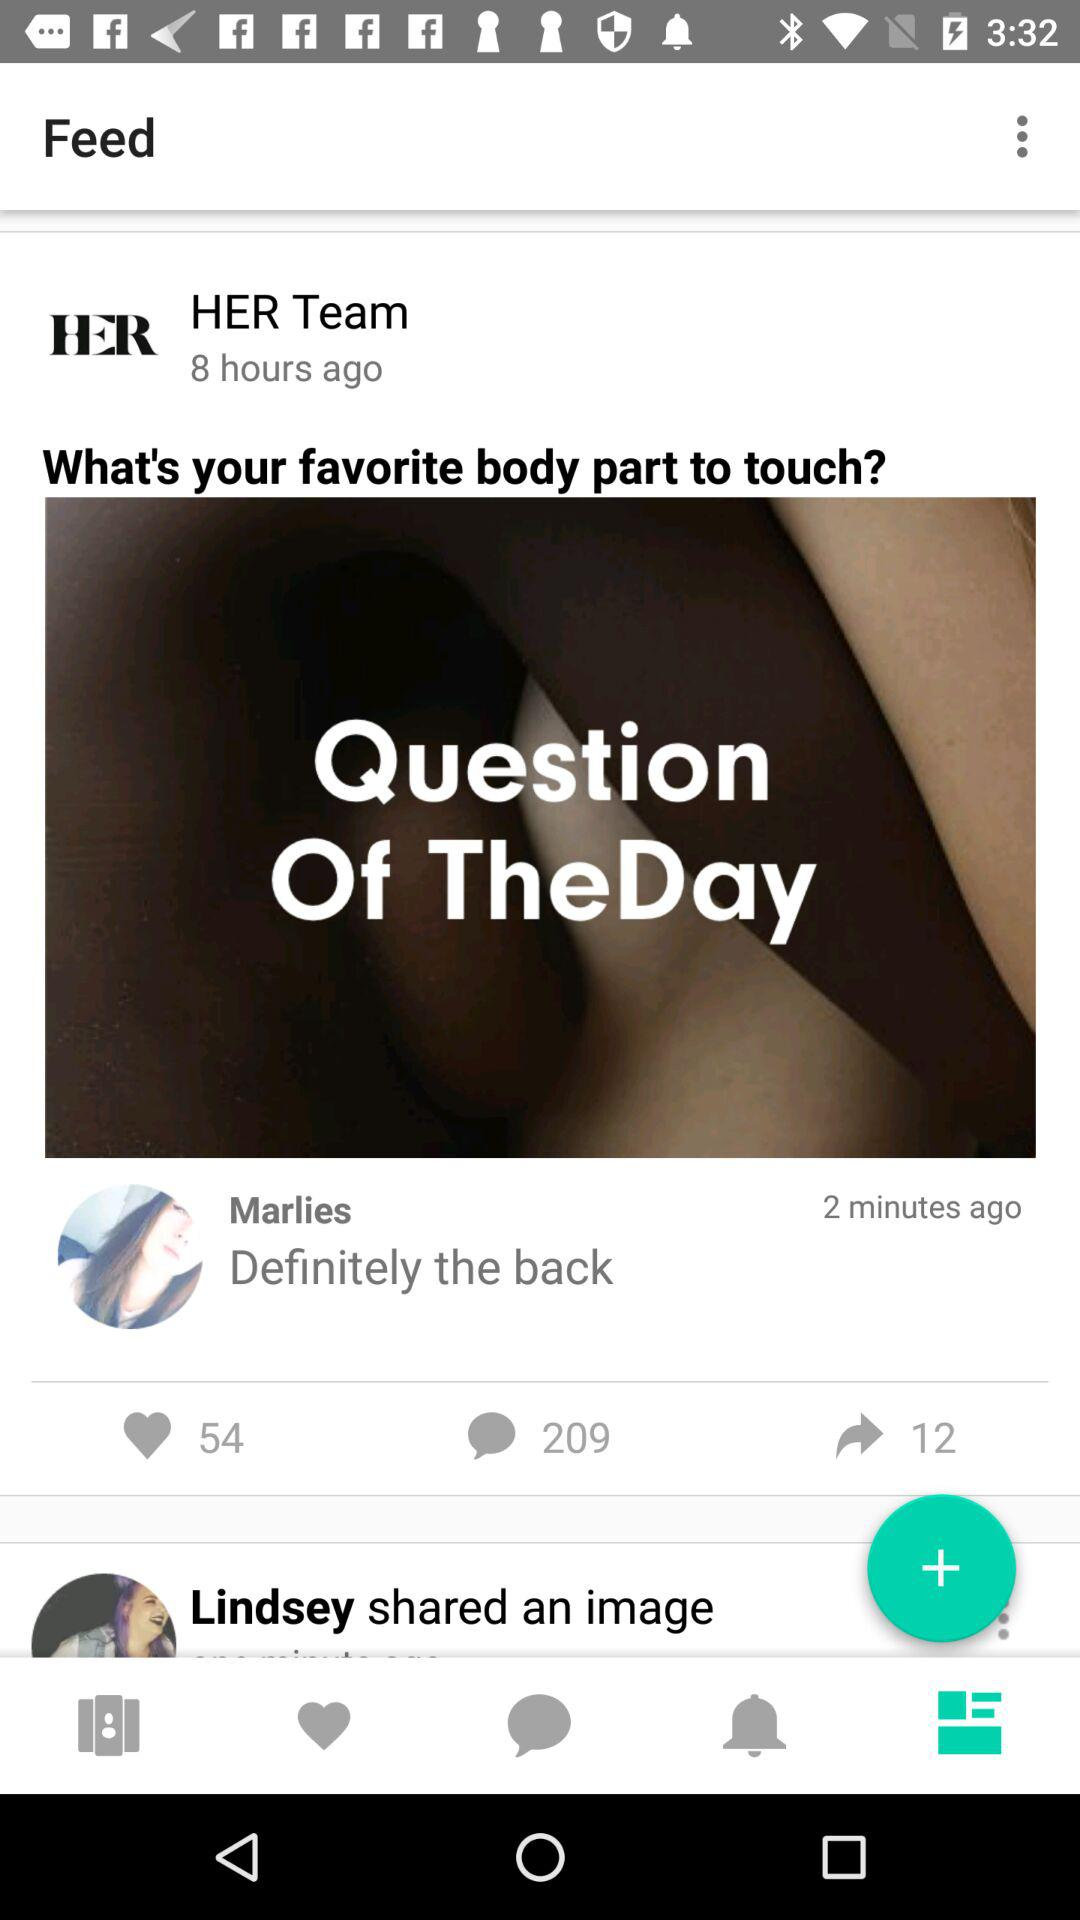On what day did Marlies comment?
When the provided information is insufficient, respond with <no answer>. <no answer> 